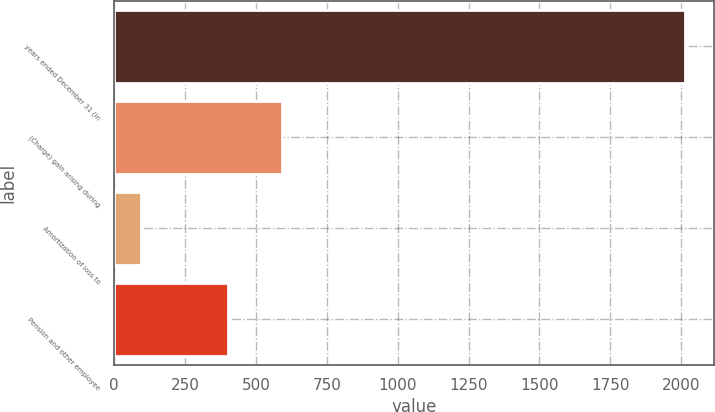Convert chart. <chart><loc_0><loc_0><loc_500><loc_500><bar_chart><fcel>years ended December 31 (in<fcel>(Charge) gain arising during<fcel>Amortization of loss to<fcel>Pension and other employee<nl><fcel>2014<fcel>592<fcel>94<fcel>400<nl></chart> 